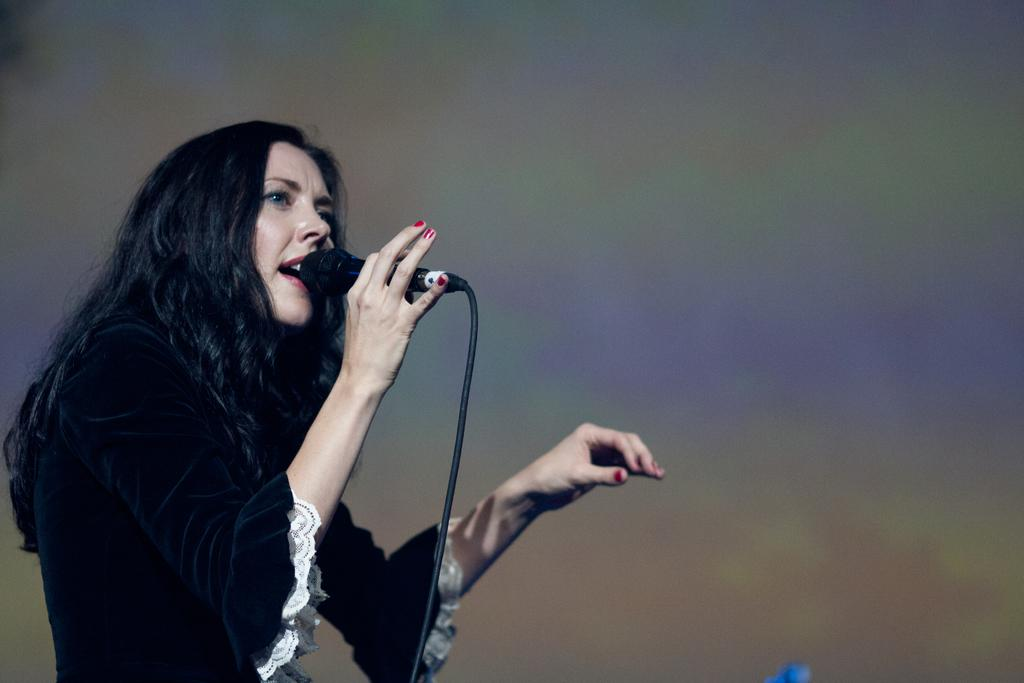Who is the main subject in the image? There is a woman in the image. What is the woman wearing? The woman is wearing a black dress. What is the woman holding in the image? The woman is holding a microphone. What is the woman doing in the image? The woman is singing. Can you describe the background of the image? The background of the image is blurred. Can you see any elbows in the image? There is no mention of elbows in the provided facts, and therefore it cannot be determined if any elbows are visible in the image. 